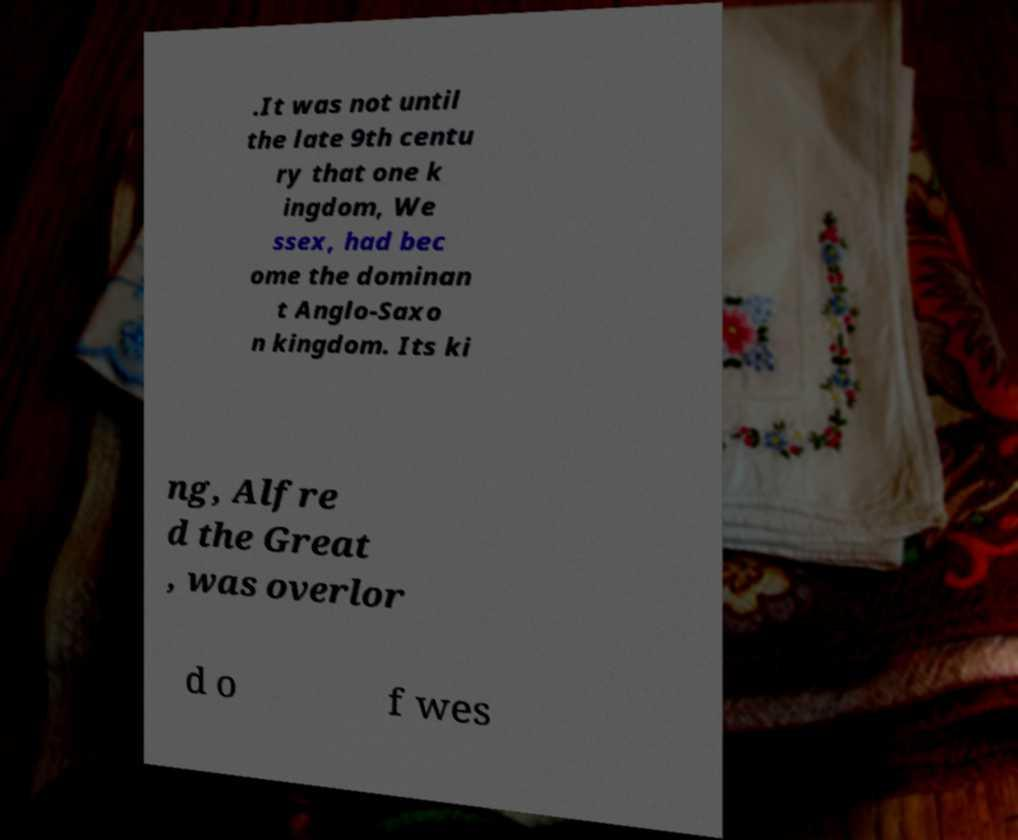What messages or text are displayed in this image? I need them in a readable, typed format. .It was not until the late 9th centu ry that one k ingdom, We ssex, had bec ome the dominan t Anglo-Saxo n kingdom. Its ki ng, Alfre d the Great , was overlor d o f wes 